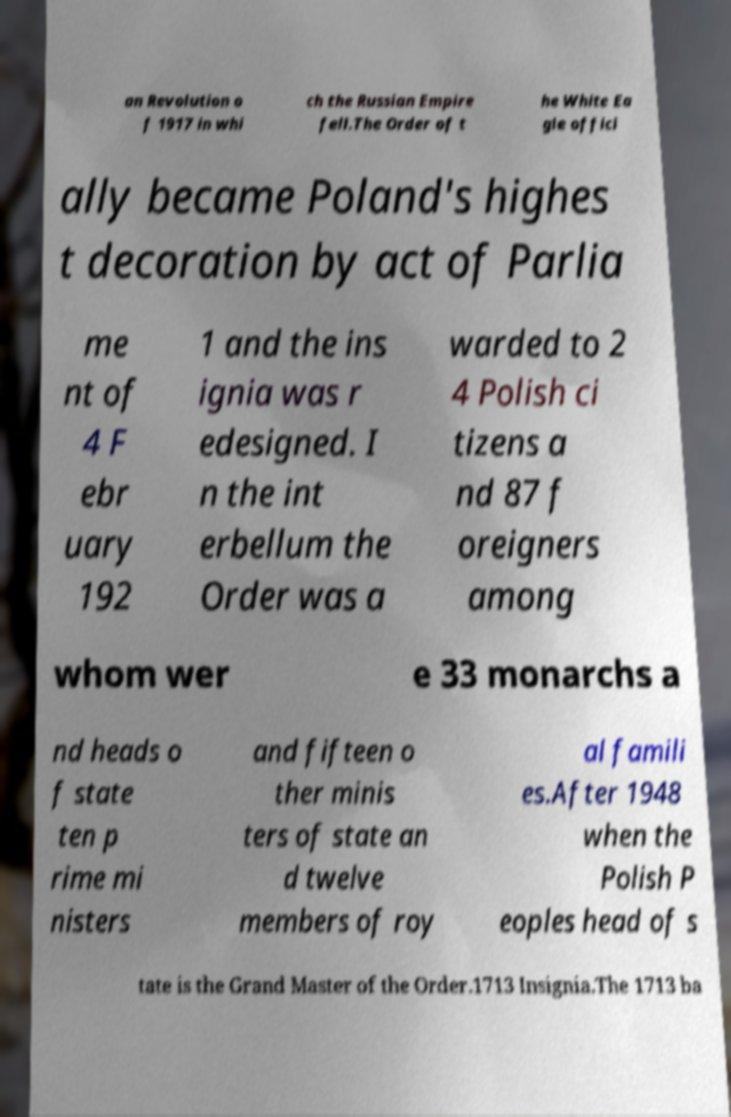Could you extract and type out the text from this image? an Revolution o f 1917 in whi ch the Russian Empire fell.The Order of t he White Ea gle offici ally became Poland's highes t decoration by act of Parlia me nt of 4 F ebr uary 192 1 and the ins ignia was r edesigned. I n the int erbellum the Order was a warded to 2 4 Polish ci tizens a nd 87 f oreigners among whom wer e 33 monarchs a nd heads o f state ten p rime mi nisters and fifteen o ther minis ters of state an d twelve members of roy al famili es.After 1948 when the Polish P eoples head of s tate is the Grand Master of the Order.1713 Insignia.The 1713 ba 